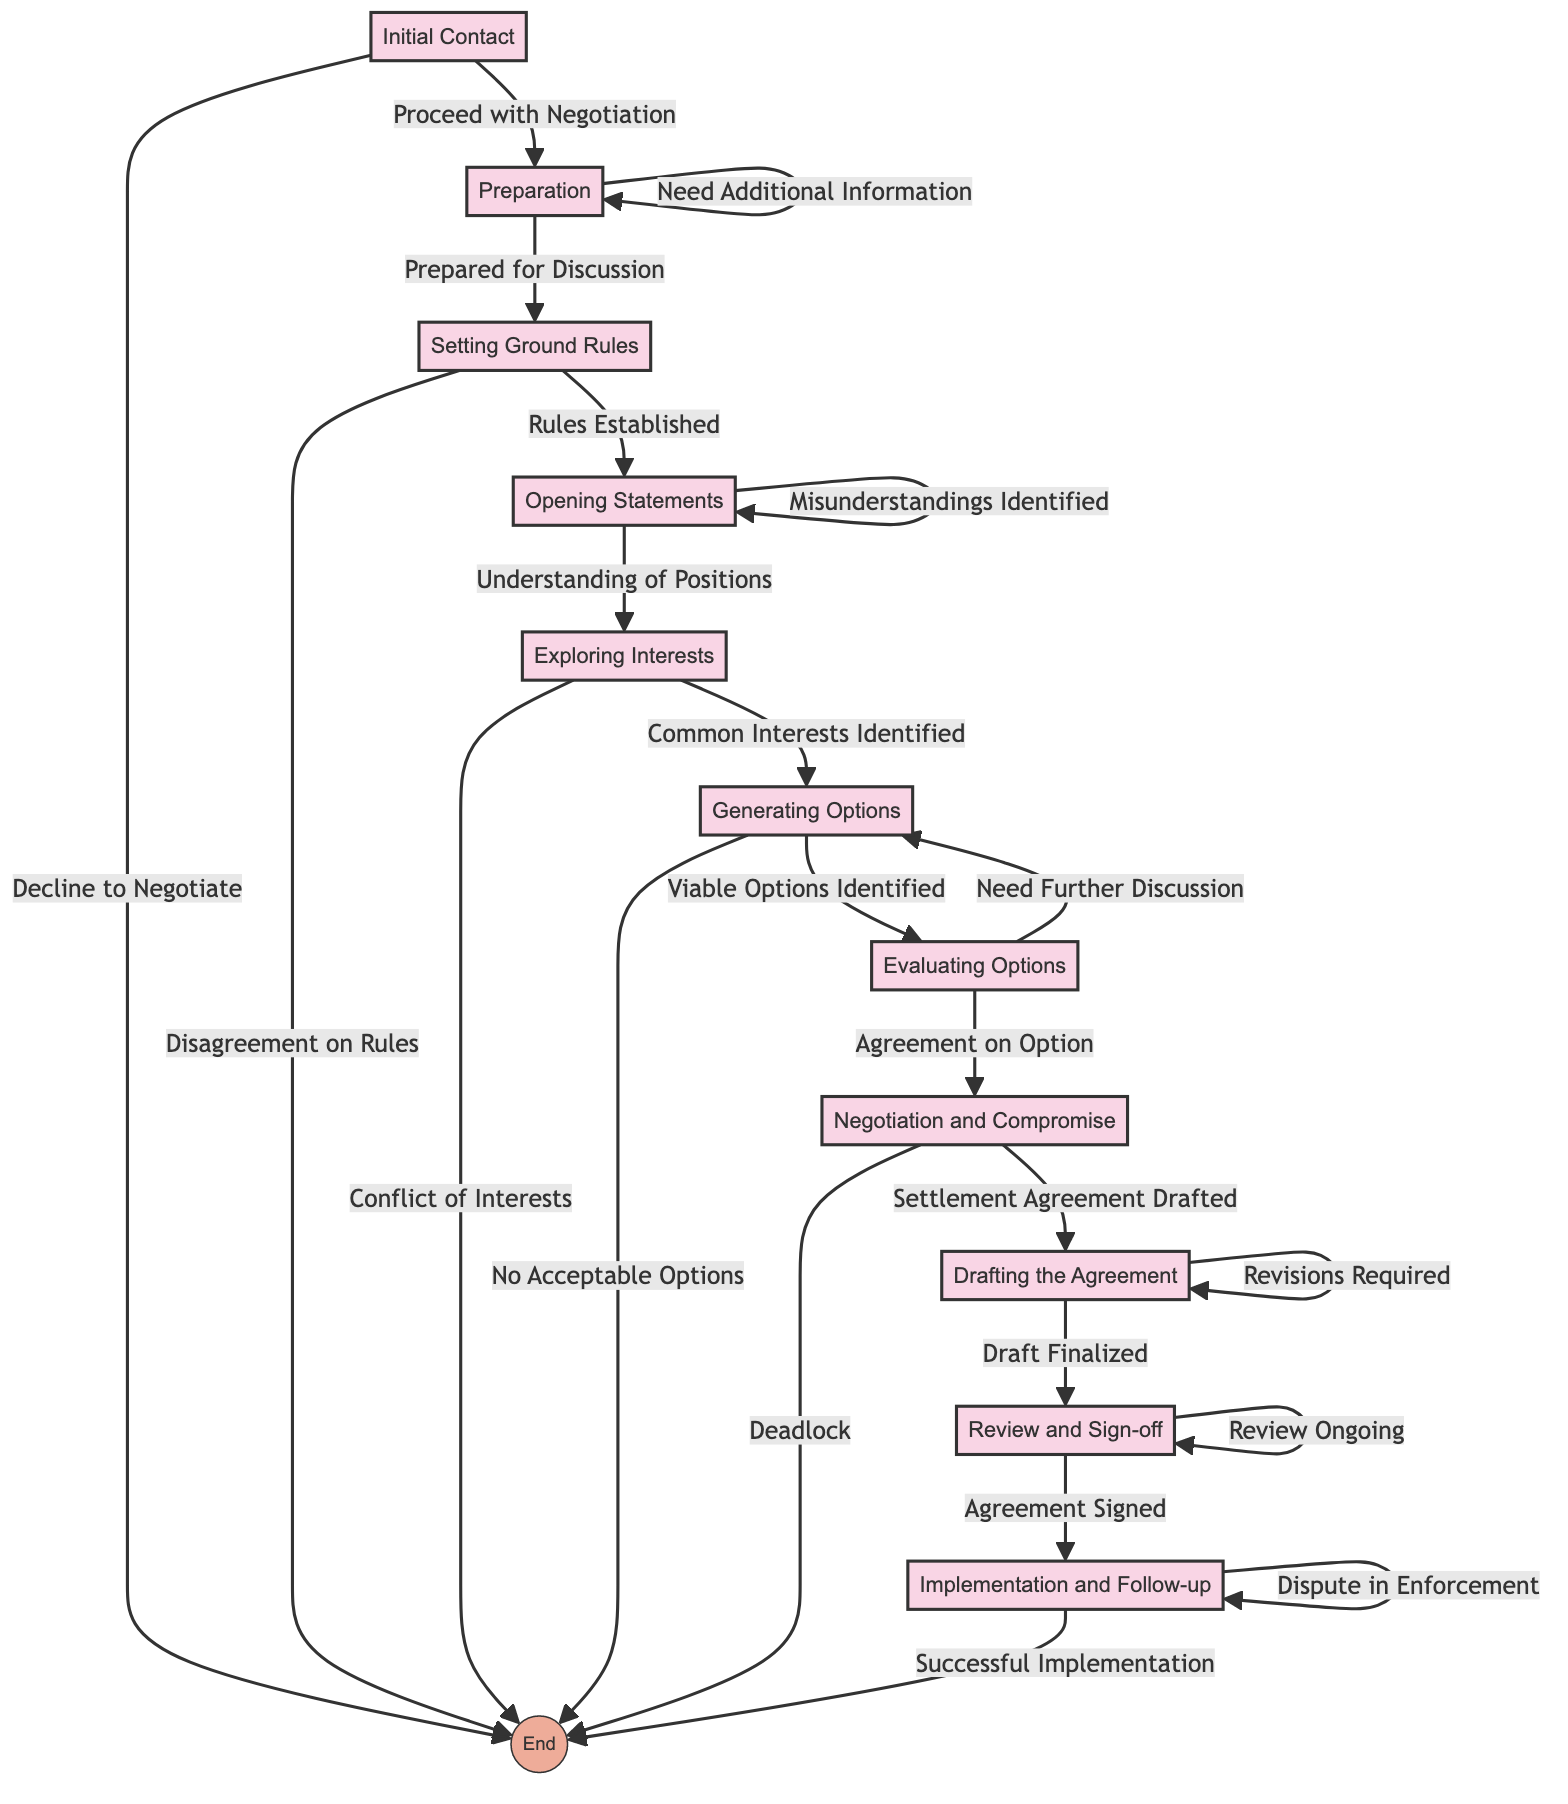What is the first step in the negotiation process? The first step listed in the diagram is "Initial Contact". This step involves parties establishing communication and expressing willingness to negotiate which is depicted as the starting point of the flow chart.
Answer: Initial Contact What are the outcomes after the "Preparation" step? After the "Preparation" step, the two possible outcomes are "Prepared for Discussion" and "Need Additional Information". These are shown as branches stemming from the "Preparation" node.
Answer: Prepared for Discussion, Need Additional Information How many total steps are there in the flow chart? The flow chart has a total of ten steps, each representing a major phase in the negotiation process, beginning with "Initial Contact" and ending with "Implementation and Follow-up".
Answer: 10 What happens if there is a "Deadlock" during negotiation? If a deadlock occurs during negotiation, the flow chart indicates that the process ends, which leads to an exit node signifying that no settlement agreement can be reached.
Answer: End Which step involves both parties presenting their positions? The step where both parties present their initial positions and desired outcomes is called "Opening Statements". This is the node that leads to further exploration of interests.
Answer: Opening Statements What follows if "Common Interests Identified" in the "Exploring Interests" step? If "Common Interests Identified" is achieved in the "Exploring Interests" step, it leads to the next step called "Generating Options". This implies a progression towards collaboratively finding solutions.
Answer: Generating Options During which step can parties engage in compromise? Parties engage in compromise during the "Negotiation and Compromise" step. At this stage, they negotiate terms and seek mutually acceptable solutions, which is delineated in the diagram.
Answer: Negotiation and Compromise What is the outcome of the "Drafting the Agreement" step if revisions are required? If revisions are required after the "Drafting the Agreement" step, the process loops back to the same step, indicating that further modifications are needed before finalization.
Answer: Revisions Required If both parties agree on an option, what is the next step? If both parties reach an agreement on an option during the "Evaluating Options" step, the next step is "Negotiation and Compromise", where they work out the details of their agreement.
Answer: Negotiation and Compromise What step occurs after the "Review and Sign-off"? After the "Review and Sign-off" step, the next step is "Implementation and Follow-up", which involves executing the agreement terms and ensuring compliance.
Answer: Implementation and Follow-up 